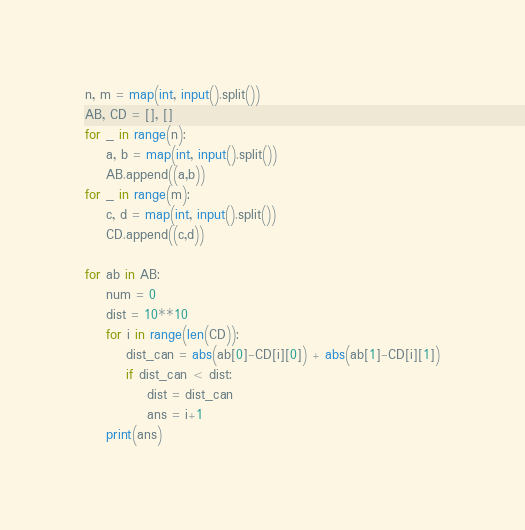<code> <loc_0><loc_0><loc_500><loc_500><_Python_>n, m = map(int, input().split())
AB, CD = [], []
for _ in range(n):
    a, b = map(int, input().split())
    AB.append((a,b))
for _ in range(m):
    c, d = map(int, input().split())
    CD.append((c,d))

for ab in AB:
    num = 0
    dist = 10**10
    for i in range(len(CD)):
        dist_can = abs(ab[0]-CD[i][0]) + abs(ab[1]-CD[i][1])
        if dist_can < dist:
            dist = dist_can
            ans = i+1
    print(ans)</code> 